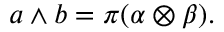Convert formula to latex. <formula><loc_0><loc_0><loc_500><loc_500>a \wedge b = \pi ( \alpha \otimes \beta ) .</formula> 